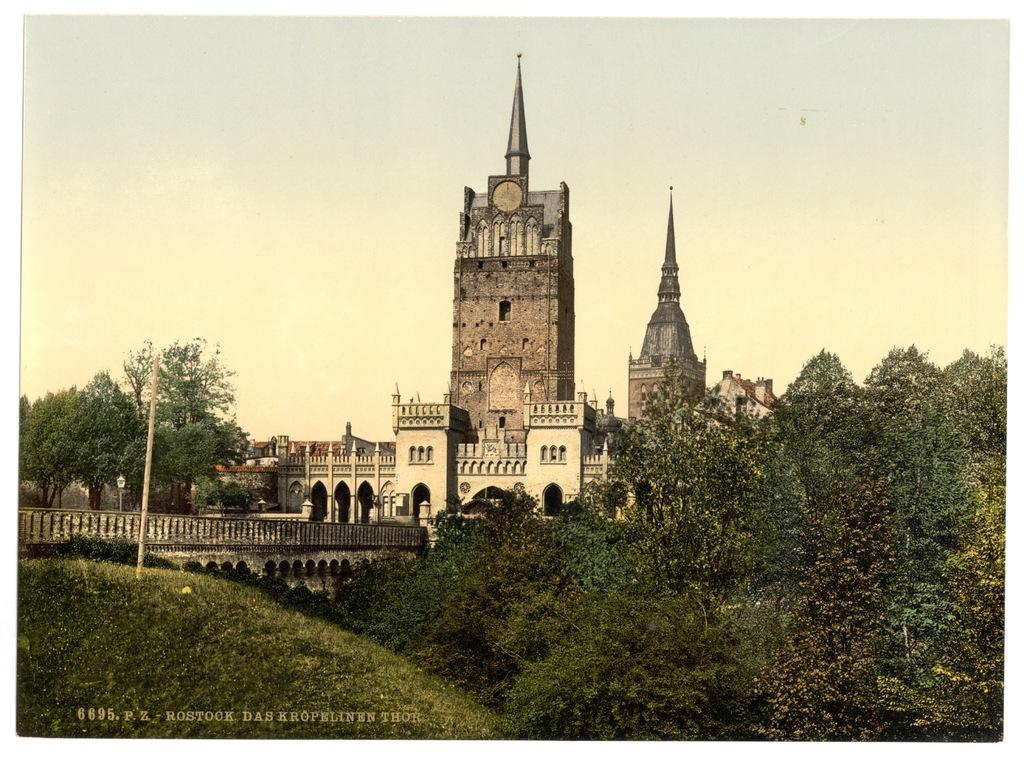What type of structures can be seen in the image? There are buildings in the image. What type of vegetation is present in the image? There are trees in the image. What are the poles used for in the image? The purpose of the poles is not specified, but they are visible in the image. What is the ground covered with in the image? There is grass on the ground in the image. What connects two areas in the image? There is a bridge in the image that connects two areas. What can be seen in the background of the image? The sky is visible in the background of the image. What type of attention is required for the operation of the bridge in the image? There is no indication in the image that the bridge requires any specific type of attention or operation. 